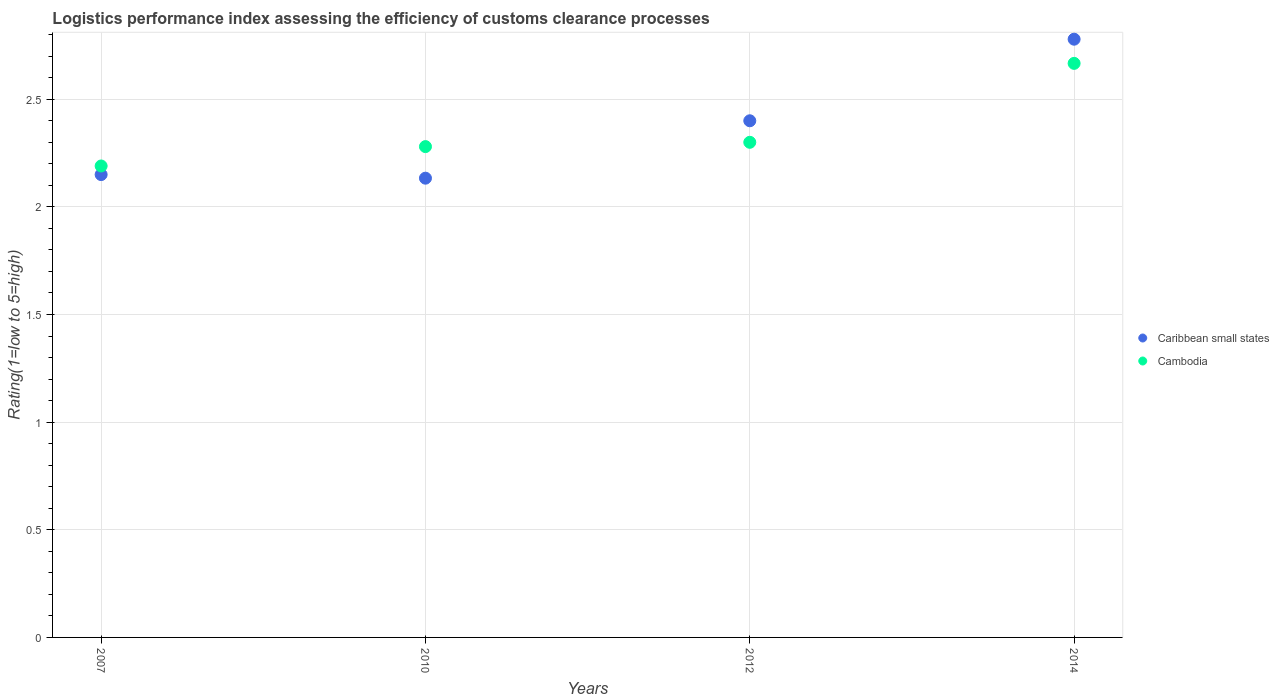Is the number of dotlines equal to the number of legend labels?
Your response must be concise. Yes. What is the Logistic performance index in Caribbean small states in 2012?
Your answer should be very brief. 2.4. Across all years, what is the maximum Logistic performance index in Caribbean small states?
Keep it short and to the point. 2.78. Across all years, what is the minimum Logistic performance index in Cambodia?
Ensure brevity in your answer.  2.19. In which year was the Logistic performance index in Cambodia maximum?
Provide a succinct answer. 2014. What is the total Logistic performance index in Caribbean small states in the graph?
Provide a short and direct response. 9.46. What is the difference between the Logistic performance index in Caribbean small states in 2010 and that in 2012?
Keep it short and to the point. -0.27. What is the difference between the Logistic performance index in Caribbean small states in 2014 and the Logistic performance index in Cambodia in 2012?
Offer a terse response. 0.48. What is the average Logistic performance index in Cambodia per year?
Your answer should be very brief. 2.36. In the year 2007, what is the difference between the Logistic performance index in Caribbean small states and Logistic performance index in Cambodia?
Your answer should be compact. -0.04. In how many years, is the Logistic performance index in Cambodia greater than 0.9?
Your answer should be very brief. 4. What is the ratio of the Logistic performance index in Cambodia in 2012 to that in 2014?
Offer a terse response. 0.86. Is the difference between the Logistic performance index in Caribbean small states in 2010 and 2014 greater than the difference between the Logistic performance index in Cambodia in 2010 and 2014?
Offer a terse response. No. What is the difference between the highest and the second highest Logistic performance index in Cambodia?
Make the answer very short. 0.37. What is the difference between the highest and the lowest Logistic performance index in Cambodia?
Provide a short and direct response. 0.48. In how many years, is the Logistic performance index in Cambodia greater than the average Logistic performance index in Cambodia taken over all years?
Provide a succinct answer. 1. Is the sum of the Logistic performance index in Caribbean small states in 2010 and 2012 greater than the maximum Logistic performance index in Cambodia across all years?
Your answer should be compact. Yes. Does the Logistic performance index in Cambodia monotonically increase over the years?
Offer a very short reply. Yes. How many dotlines are there?
Provide a succinct answer. 2. How many years are there in the graph?
Provide a succinct answer. 4. Does the graph contain any zero values?
Offer a very short reply. No. Where does the legend appear in the graph?
Your answer should be very brief. Center right. How are the legend labels stacked?
Make the answer very short. Vertical. What is the title of the graph?
Keep it short and to the point. Logistics performance index assessing the efficiency of customs clearance processes. What is the label or title of the X-axis?
Provide a succinct answer. Years. What is the label or title of the Y-axis?
Ensure brevity in your answer.  Rating(1=low to 5=high). What is the Rating(1=low to 5=high) in Caribbean small states in 2007?
Your answer should be very brief. 2.15. What is the Rating(1=low to 5=high) of Cambodia in 2007?
Ensure brevity in your answer.  2.19. What is the Rating(1=low to 5=high) of Caribbean small states in 2010?
Make the answer very short. 2.13. What is the Rating(1=low to 5=high) of Cambodia in 2010?
Your answer should be very brief. 2.28. What is the Rating(1=low to 5=high) in Caribbean small states in 2012?
Make the answer very short. 2.4. What is the Rating(1=low to 5=high) of Caribbean small states in 2014?
Give a very brief answer. 2.78. What is the Rating(1=low to 5=high) of Cambodia in 2014?
Give a very brief answer. 2.67. Across all years, what is the maximum Rating(1=low to 5=high) in Caribbean small states?
Keep it short and to the point. 2.78. Across all years, what is the maximum Rating(1=low to 5=high) in Cambodia?
Keep it short and to the point. 2.67. Across all years, what is the minimum Rating(1=low to 5=high) in Caribbean small states?
Offer a terse response. 2.13. Across all years, what is the minimum Rating(1=low to 5=high) in Cambodia?
Your answer should be compact. 2.19. What is the total Rating(1=low to 5=high) of Caribbean small states in the graph?
Provide a succinct answer. 9.46. What is the total Rating(1=low to 5=high) of Cambodia in the graph?
Your response must be concise. 9.44. What is the difference between the Rating(1=low to 5=high) of Caribbean small states in 2007 and that in 2010?
Offer a very short reply. 0.02. What is the difference between the Rating(1=low to 5=high) in Cambodia in 2007 and that in 2010?
Make the answer very short. -0.09. What is the difference between the Rating(1=low to 5=high) of Caribbean small states in 2007 and that in 2012?
Your answer should be compact. -0.25. What is the difference between the Rating(1=low to 5=high) in Cambodia in 2007 and that in 2012?
Make the answer very short. -0.11. What is the difference between the Rating(1=low to 5=high) of Caribbean small states in 2007 and that in 2014?
Ensure brevity in your answer.  -0.63. What is the difference between the Rating(1=low to 5=high) in Cambodia in 2007 and that in 2014?
Offer a terse response. -0.48. What is the difference between the Rating(1=low to 5=high) in Caribbean small states in 2010 and that in 2012?
Give a very brief answer. -0.27. What is the difference between the Rating(1=low to 5=high) of Cambodia in 2010 and that in 2012?
Your response must be concise. -0.02. What is the difference between the Rating(1=low to 5=high) of Caribbean small states in 2010 and that in 2014?
Your answer should be compact. -0.65. What is the difference between the Rating(1=low to 5=high) in Cambodia in 2010 and that in 2014?
Provide a short and direct response. -0.39. What is the difference between the Rating(1=low to 5=high) of Caribbean small states in 2012 and that in 2014?
Your response must be concise. -0.38. What is the difference between the Rating(1=low to 5=high) in Cambodia in 2012 and that in 2014?
Your answer should be very brief. -0.37. What is the difference between the Rating(1=low to 5=high) in Caribbean small states in 2007 and the Rating(1=low to 5=high) in Cambodia in 2010?
Offer a very short reply. -0.13. What is the difference between the Rating(1=low to 5=high) of Caribbean small states in 2007 and the Rating(1=low to 5=high) of Cambodia in 2014?
Offer a terse response. -0.52. What is the difference between the Rating(1=low to 5=high) in Caribbean small states in 2010 and the Rating(1=low to 5=high) in Cambodia in 2014?
Offer a terse response. -0.53. What is the difference between the Rating(1=low to 5=high) of Caribbean small states in 2012 and the Rating(1=low to 5=high) of Cambodia in 2014?
Your response must be concise. -0.27. What is the average Rating(1=low to 5=high) in Caribbean small states per year?
Offer a terse response. 2.37. What is the average Rating(1=low to 5=high) in Cambodia per year?
Make the answer very short. 2.36. In the year 2007, what is the difference between the Rating(1=low to 5=high) of Caribbean small states and Rating(1=low to 5=high) of Cambodia?
Your response must be concise. -0.04. In the year 2010, what is the difference between the Rating(1=low to 5=high) in Caribbean small states and Rating(1=low to 5=high) in Cambodia?
Keep it short and to the point. -0.15. In the year 2012, what is the difference between the Rating(1=low to 5=high) of Caribbean small states and Rating(1=low to 5=high) of Cambodia?
Make the answer very short. 0.1. In the year 2014, what is the difference between the Rating(1=low to 5=high) of Caribbean small states and Rating(1=low to 5=high) of Cambodia?
Offer a very short reply. 0.11. What is the ratio of the Rating(1=low to 5=high) of Caribbean small states in 2007 to that in 2010?
Provide a succinct answer. 1.01. What is the ratio of the Rating(1=low to 5=high) of Cambodia in 2007 to that in 2010?
Your answer should be very brief. 0.96. What is the ratio of the Rating(1=low to 5=high) in Caribbean small states in 2007 to that in 2012?
Give a very brief answer. 0.9. What is the ratio of the Rating(1=low to 5=high) in Cambodia in 2007 to that in 2012?
Provide a short and direct response. 0.95. What is the ratio of the Rating(1=low to 5=high) in Caribbean small states in 2007 to that in 2014?
Keep it short and to the point. 0.77. What is the ratio of the Rating(1=low to 5=high) of Cambodia in 2007 to that in 2014?
Keep it short and to the point. 0.82. What is the ratio of the Rating(1=low to 5=high) of Cambodia in 2010 to that in 2012?
Offer a terse response. 0.99. What is the ratio of the Rating(1=low to 5=high) of Caribbean small states in 2010 to that in 2014?
Offer a very short reply. 0.77. What is the ratio of the Rating(1=low to 5=high) of Cambodia in 2010 to that in 2014?
Give a very brief answer. 0.85. What is the ratio of the Rating(1=low to 5=high) of Caribbean small states in 2012 to that in 2014?
Offer a very short reply. 0.86. What is the ratio of the Rating(1=low to 5=high) in Cambodia in 2012 to that in 2014?
Keep it short and to the point. 0.86. What is the difference between the highest and the second highest Rating(1=low to 5=high) of Caribbean small states?
Provide a succinct answer. 0.38. What is the difference between the highest and the second highest Rating(1=low to 5=high) in Cambodia?
Your answer should be very brief. 0.37. What is the difference between the highest and the lowest Rating(1=low to 5=high) of Caribbean small states?
Make the answer very short. 0.65. What is the difference between the highest and the lowest Rating(1=low to 5=high) of Cambodia?
Your answer should be very brief. 0.48. 